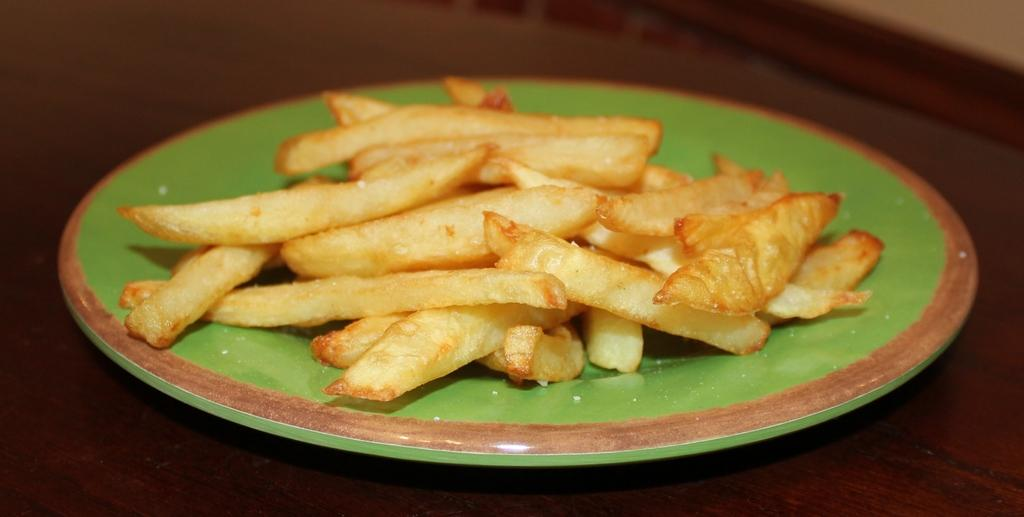What type of food is on the plate in the image? There are french fries on a plate in the image. What is the color of the plate? The plate is colored green. How many pies are on the plate in the image? There are no pies present in the image; it features a plate of french fries. 